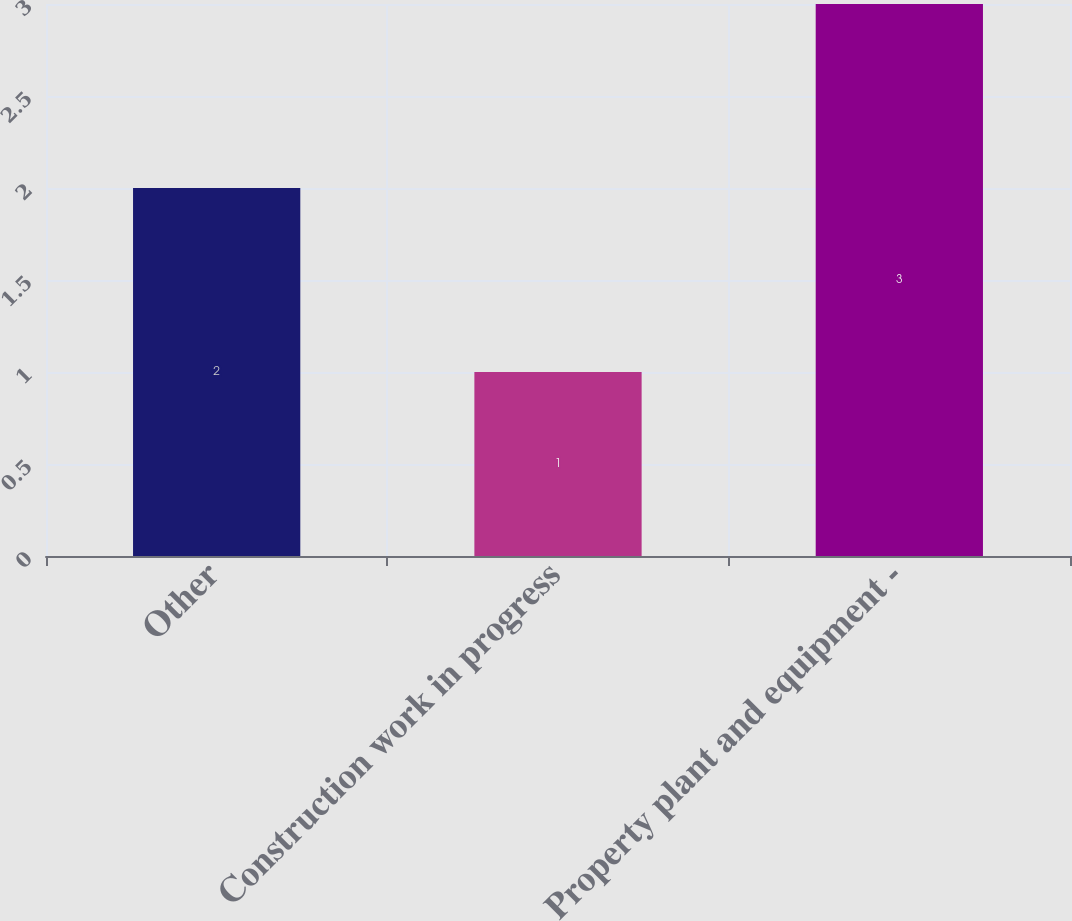Convert chart. <chart><loc_0><loc_0><loc_500><loc_500><bar_chart><fcel>Other<fcel>Construction work in progress<fcel>Property plant and equipment -<nl><fcel>2<fcel>1<fcel>3<nl></chart> 